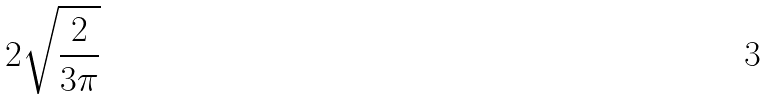<formula> <loc_0><loc_0><loc_500><loc_500>2 \sqrt { \frac { 2 } { 3 \pi } }</formula> 